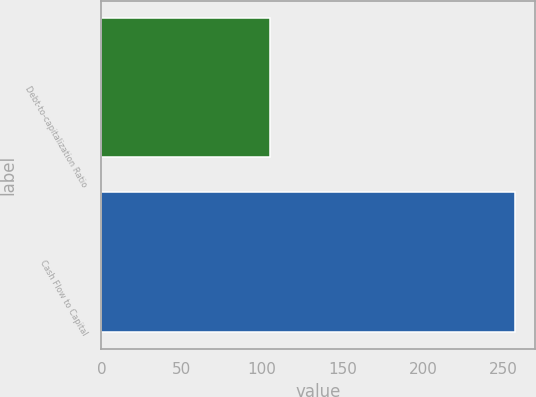Convert chart. <chart><loc_0><loc_0><loc_500><loc_500><bar_chart><fcel>Debt-to-capitalization Ratio<fcel>Cash Flow to Capital<nl><fcel>105<fcel>257<nl></chart> 